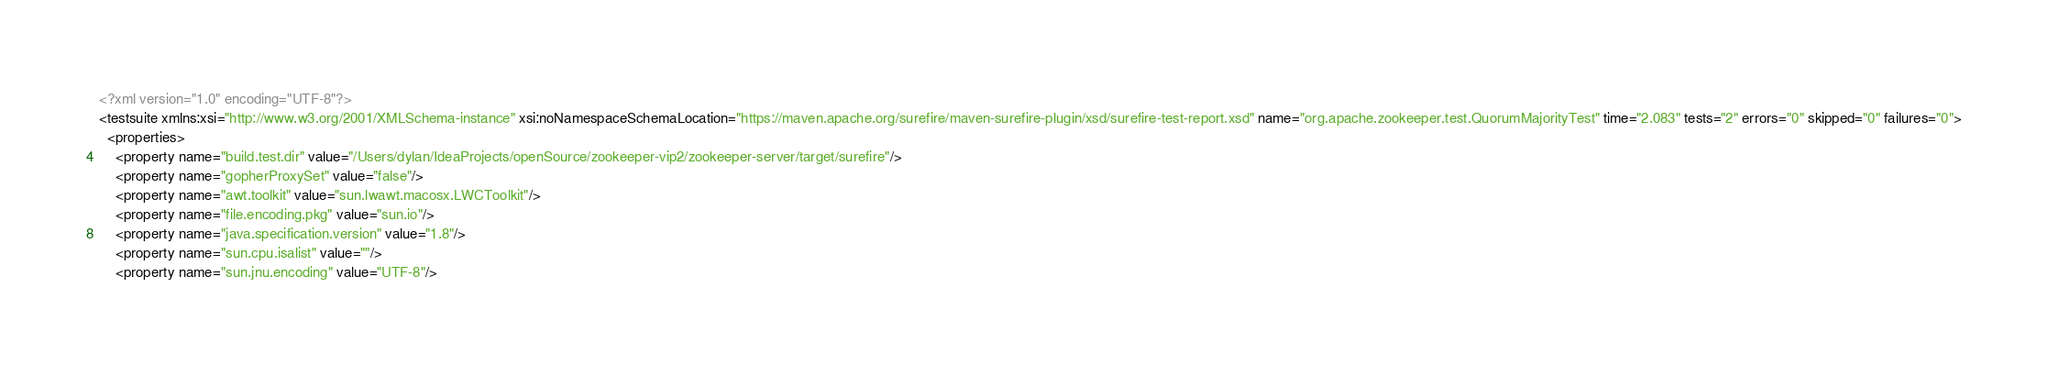<code> <loc_0><loc_0><loc_500><loc_500><_XML_><?xml version="1.0" encoding="UTF-8"?>
<testsuite xmlns:xsi="http://www.w3.org/2001/XMLSchema-instance" xsi:noNamespaceSchemaLocation="https://maven.apache.org/surefire/maven-surefire-plugin/xsd/surefire-test-report.xsd" name="org.apache.zookeeper.test.QuorumMajorityTest" time="2.083" tests="2" errors="0" skipped="0" failures="0">
  <properties>
    <property name="build.test.dir" value="/Users/dylan/IdeaProjects/openSource/zookeeper-vip2/zookeeper-server/target/surefire"/>
    <property name="gopherProxySet" value="false"/>
    <property name="awt.toolkit" value="sun.lwawt.macosx.LWCToolkit"/>
    <property name="file.encoding.pkg" value="sun.io"/>
    <property name="java.specification.version" value="1.8"/>
    <property name="sun.cpu.isalist" value=""/>
    <property name="sun.jnu.encoding" value="UTF-8"/></code> 